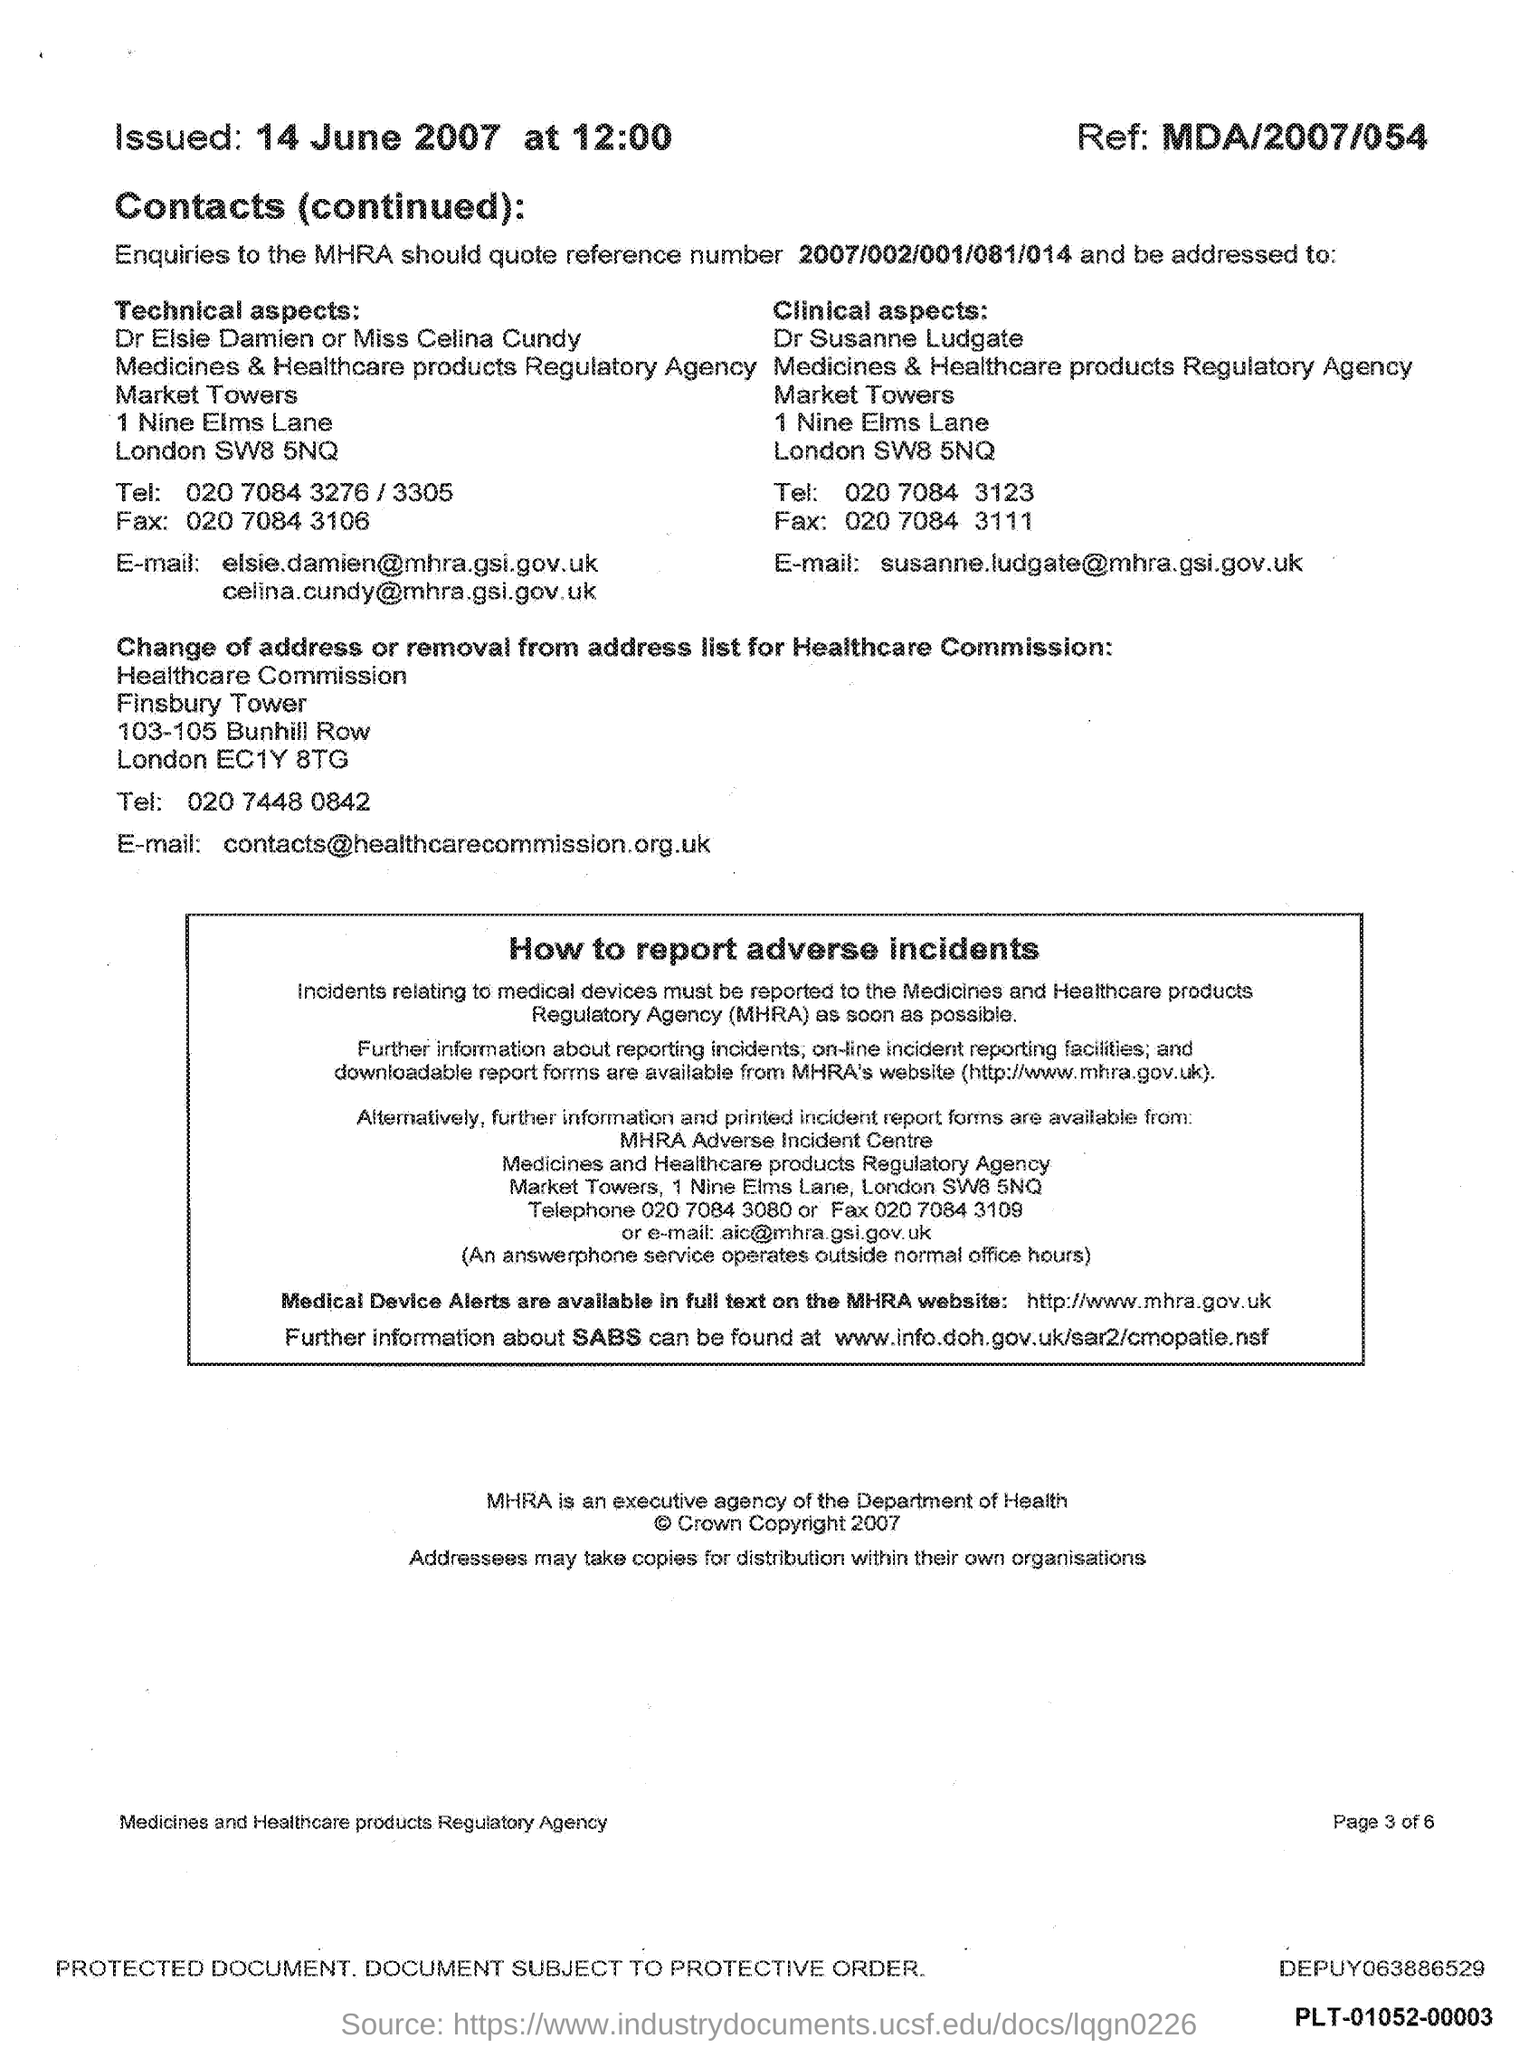Draw attention to some important aspects in this diagram. The document indicates a time of 12:00.. What ref number is mentioned in this document? MDA/2007/054... The issued date mentioned in this document is June 14th, 2007. 